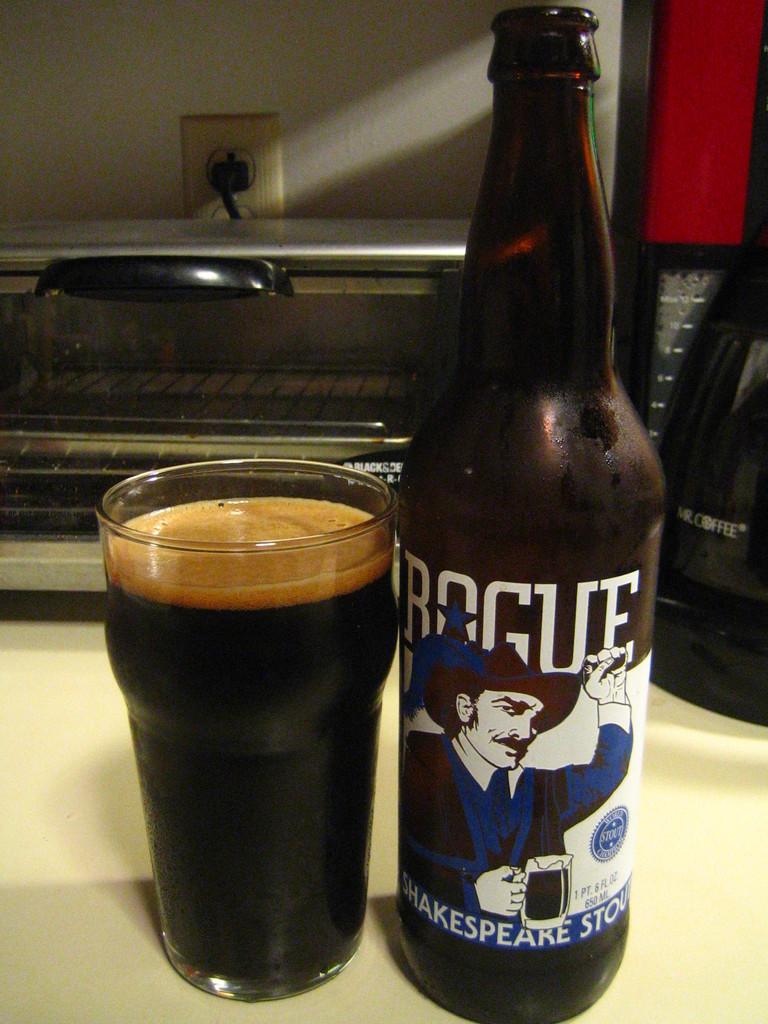What name is on the bottom of the bottle?
Your response must be concise. Shakespeare. 